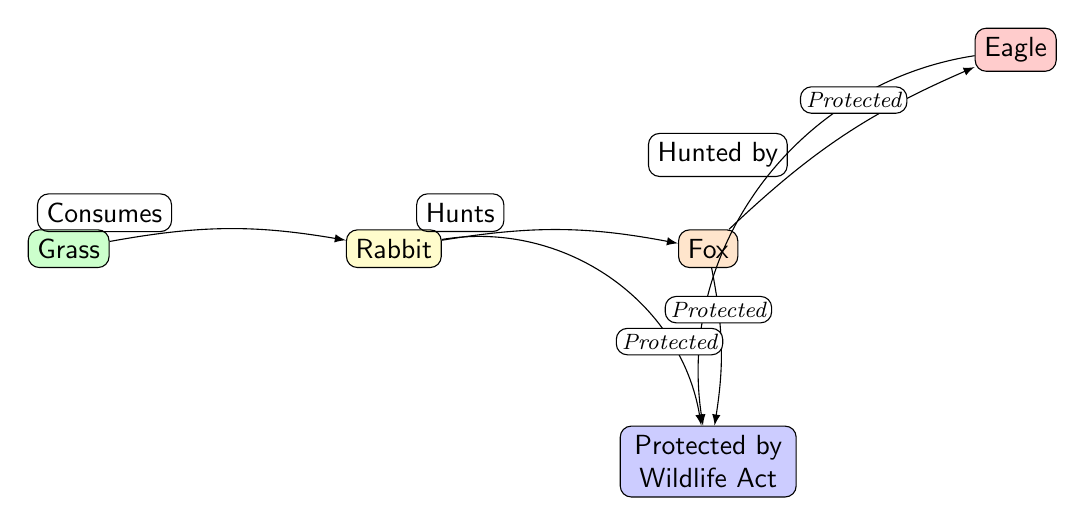What is the producer in this food chain? The diagram identifies "Grass" as the producer, which serves as the primary source of energy in this food chain.
Answer: Grass How many nodes are in the food chain? The diagram consists of five nodes: Grass, Rabbit, Fox, Eagle, and the legal protection node. Thus, the total number of nodes is determined by counting them individually.
Answer: 5 Who is the apex predator in this food chain? The apex predator in the food chain is represented by "Eagle." This can be identified as it is at the top of the food chain hierarchy, preying on the Fox.
Answer: Eagle What relationship does the rabbit have with the fox? The diagram clearly indicates a directional relationship where the fox hunts the rabbit, as labeled on the edge connecting these two nodes.
Answer: Hunts Which entities are protected by the Wildlife Act according to the diagram? The diagram shows that the law node intersects with Rabbit, Fox, and Eagle, indicating that all these entities are protected under the Wildlife Act. To find this, one must refer to the edges connecting these entities to the law node.
Answer: Rabbit, Fox, Eagle What is the prey of the fox? According to the diagram, the fox preys on the rabbit, which is shown by the directional edge labeled as such between the fox and the rabbit.
Answer: Rabbit What color represents the predators in the diagram? In the diagram, predators are represented in orange color, which is consistent for both the fox and its designation as a predator node.
Answer: Orange How many protected entities are in the food chain? The diagram indicates that three entities (Rabbit, Fox, Eagle) are protected by the Wildlife Act as shown by the connections to the legal protection node.
Answer: 3 What type of diagram is this one categorized as? Based on its characteristics and the content depicted, this diagram is categorized as a Natural Science Diagram, specifically illustrating a food chain in an ecosystem.
Answer: Natural Science Diagram 